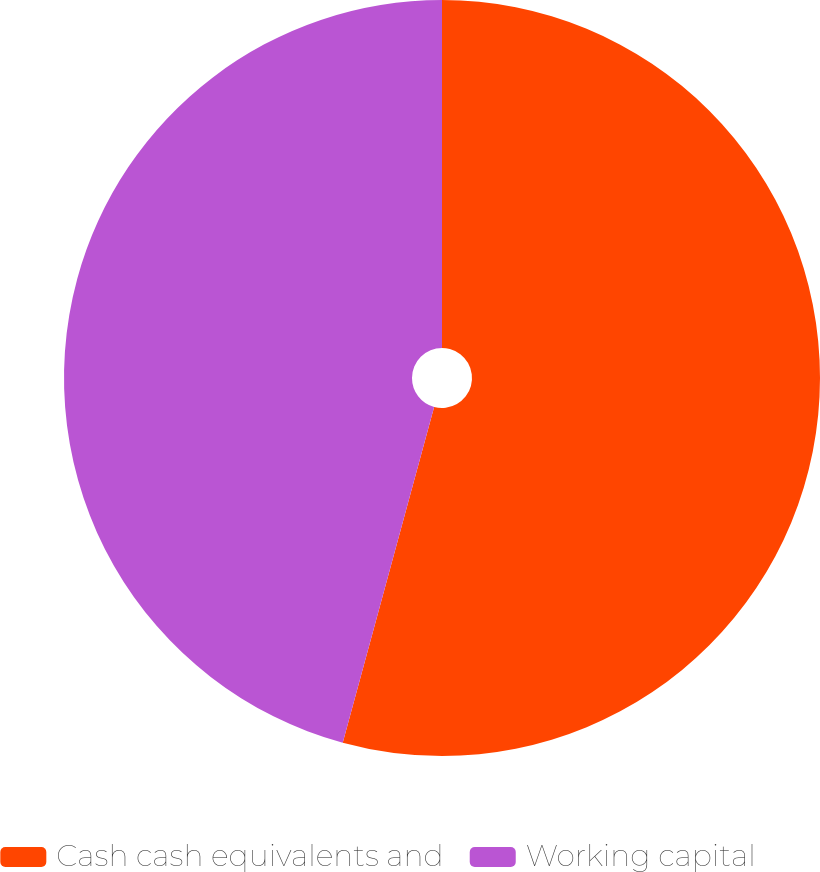Convert chart. <chart><loc_0><loc_0><loc_500><loc_500><pie_chart><fcel>Cash cash equivalents and<fcel>Working capital<nl><fcel>54.23%<fcel>45.77%<nl></chart> 